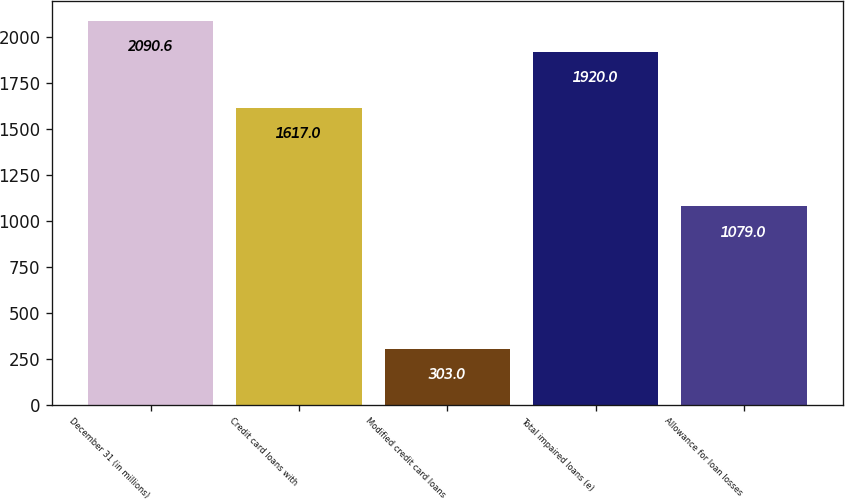<chart> <loc_0><loc_0><loc_500><loc_500><bar_chart><fcel>December 31 (in millions)<fcel>Credit card loans with<fcel>Modified credit card loans<fcel>Total impaired loans (e)<fcel>Allowance for loan losses<nl><fcel>2090.6<fcel>1617<fcel>303<fcel>1920<fcel>1079<nl></chart> 